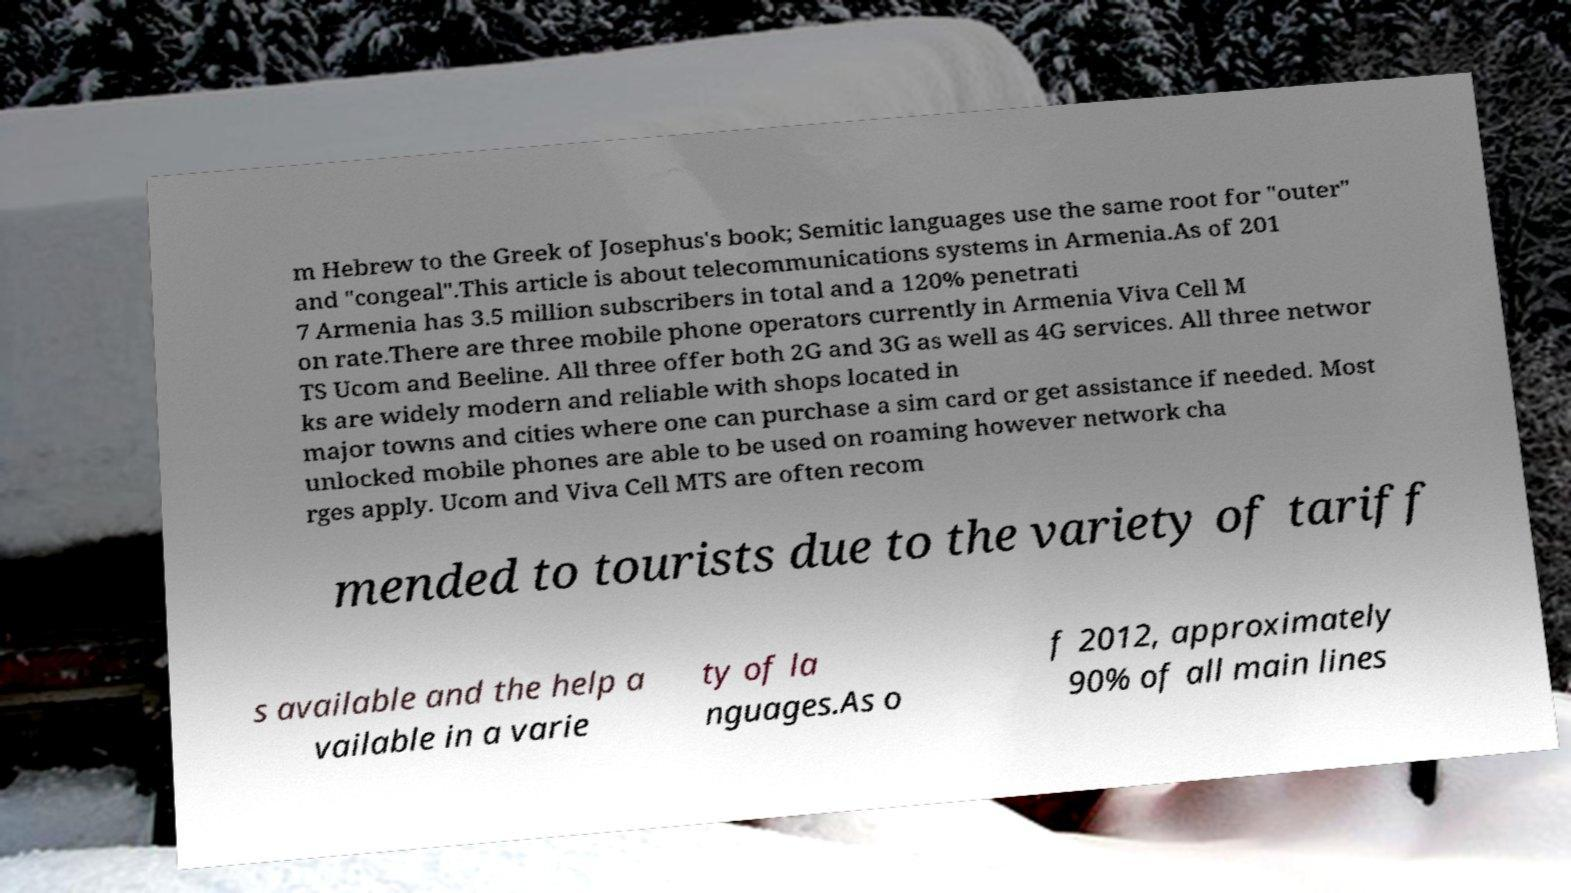What messages or text are displayed in this image? I need them in a readable, typed format. m Hebrew to the Greek of Josephus's book; Semitic languages use the same root for "outer" and "congeal".This article is about telecommunications systems in Armenia.As of 201 7 Armenia has 3.5 million subscribers in total and a 120% penetrati on rate.There are three mobile phone operators currently in Armenia Viva Cell M TS Ucom and Beeline. All three offer both 2G and 3G as well as 4G services. All three networ ks are widely modern and reliable with shops located in major towns and cities where one can purchase a sim card or get assistance if needed. Most unlocked mobile phones are able to be used on roaming however network cha rges apply. Ucom and Viva Cell MTS are often recom mended to tourists due to the variety of tariff s available and the help a vailable in a varie ty of la nguages.As o f 2012, approximately 90% of all main lines 